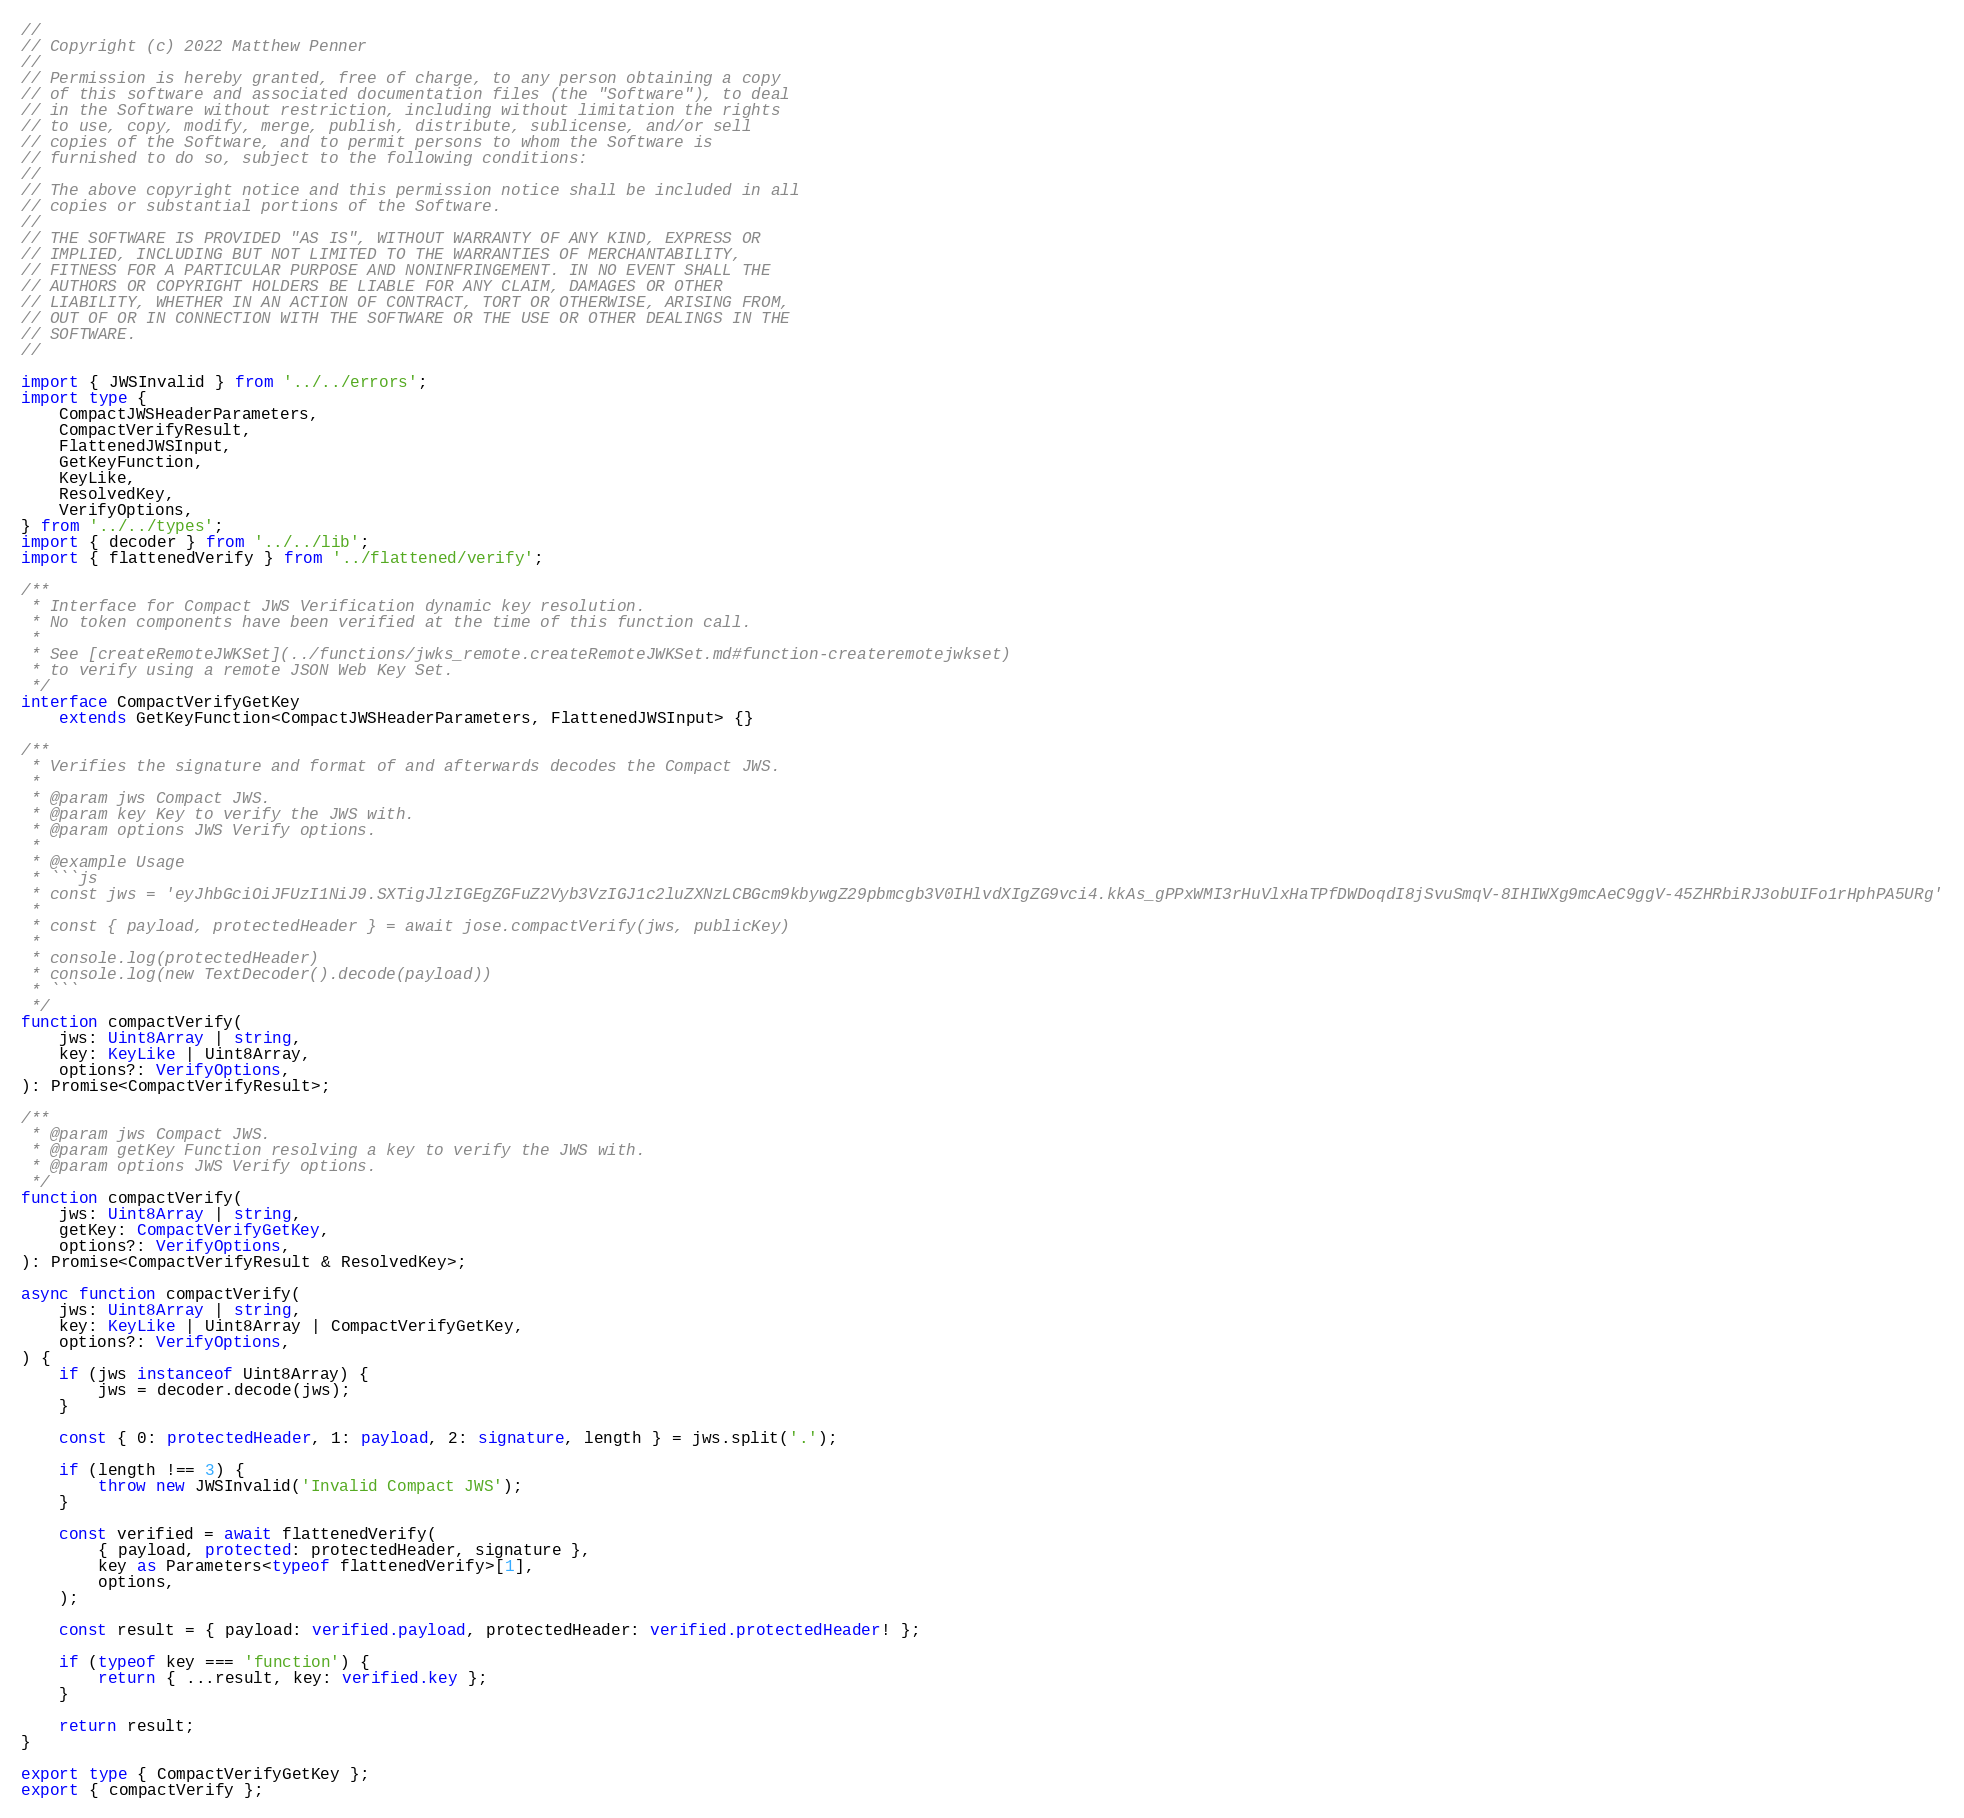Convert code to text. <code><loc_0><loc_0><loc_500><loc_500><_TypeScript_>//
// Copyright (c) 2022 Matthew Penner
//
// Permission is hereby granted, free of charge, to any person obtaining a copy
// of this software and associated documentation files (the "Software"), to deal
// in the Software without restriction, including without limitation the rights
// to use, copy, modify, merge, publish, distribute, sublicense, and/or sell
// copies of the Software, and to permit persons to whom the Software is
// furnished to do so, subject to the following conditions:
//
// The above copyright notice and this permission notice shall be included in all
// copies or substantial portions of the Software.
//
// THE SOFTWARE IS PROVIDED "AS IS", WITHOUT WARRANTY OF ANY KIND, EXPRESS OR
// IMPLIED, INCLUDING BUT NOT LIMITED TO THE WARRANTIES OF MERCHANTABILITY,
// FITNESS FOR A PARTICULAR PURPOSE AND NONINFRINGEMENT. IN NO EVENT SHALL THE
// AUTHORS OR COPYRIGHT HOLDERS BE LIABLE FOR ANY CLAIM, DAMAGES OR OTHER
// LIABILITY, WHETHER IN AN ACTION OF CONTRACT, TORT OR OTHERWISE, ARISING FROM,
// OUT OF OR IN CONNECTION WITH THE SOFTWARE OR THE USE OR OTHER DEALINGS IN THE
// SOFTWARE.
//

import { JWSInvalid } from '../../errors';
import type {
	CompactJWSHeaderParameters,
	CompactVerifyResult,
	FlattenedJWSInput,
	GetKeyFunction,
	KeyLike,
	ResolvedKey,
	VerifyOptions,
} from '../../types';
import { decoder } from '../../lib';
import { flattenedVerify } from '../flattened/verify';

/**
 * Interface for Compact JWS Verification dynamic key resolution.
 * No token components have been verified at the time of this function call.
 *
 * See [createRemoteJWKSet](../functions/jwks_remote.createRemoteJWKSet.md#function-createremotejwkset)
 * to verify using a remote JSON Web Key Set.
 */
interface CompactVerifyGetKey
	extends GetKeyFunction<CompactJWSHeaderParameters, FlattenedJWSInput> {}

/**
 * Verifies the signature and format of and afterwards decodes the Compact JWS.
 *
 * @param jws Compact JWS.
 * @param key Key to verify the JWS with.
 * @param options JWS Verify options.
 *
 * @example Usage
 * ```js
 * const jws = 'eyJhbGciOiJFUzI1NiJ9.SXTigJlzIGEgZGFuZ2Vyb3VzIGJ1c2luZXNzLCBGcm9kbywgZ29pbmcgb3V0IHlvdXIgZG9vci4.kkAs_gPPxWMI3rHuVlxHaTPfDWDoqdI8jSvuSmqV-8IHIWXg9mcAeC9ggV-45ZHRbiRJ3obUIFo1rHphPA5URg'
 *
 * const { payload, protectedHeader } = await jose.compactVerify(jws, publicKey)
 *
 * console.log(protectedHeader)
 * console.log(new TextDecoder().decode(payload))
 * ```
 */
function compactVerify(
	jws: Uint8Array | string,
	key: KeyLike | Uint8Array,
	options?: VerifyOptions,
): Promise<CompactVerifyResult>;

/**
 * @param jws Compact JWS.
 * @param getKey Function resolving a key to verify the JWS with.
 * @param options JWS Verify options.
 */
function compactVerify(
	jws: Uint8Array | string,
	getKey: CompactVerifyGetKey,
	options?: VerifyOptions,
): Promise<CompactVerifyResult & ResolvedKey>;

async function compactVerify(
	jws: Uint8Array | string,
	key: KeyLike | Uint8Array | CompactVerifyGetKey,
	options?: VerifyOptions,
) {
	if (jws instanceof Uint8Array) {
		jws = decoder.decode(jws);
	}

	const { 0: protectedHeader, 1: payload, 2: signature, length } = jws.split('.');

	if (length !== 3) {
		throw new JWSInvalid('Invalid Compact JWS');
	}

	const verified = await flattenedVerify(
		{ payload, protected: protectedHeader, signature },
		key as Parameters<typeof flattenedVerify>[1],
		options,
	);

	const result = { payload: verified.payload, protectedHeader: verified.protectedHeader! };

	if (typeof key === 'function') {
		return { ...result, key: verified.key };
	}

	return result;
}

export type { CompactVerifyGetKey };
export { compactVerify };
</code> 